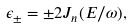Convert formula to latex. <formula><loc_0><loc_0><loc_500><loc_500>\epsilon _ { \pm } = \pm 2 J _ { n } ( E / \omega ) ,</formula> 